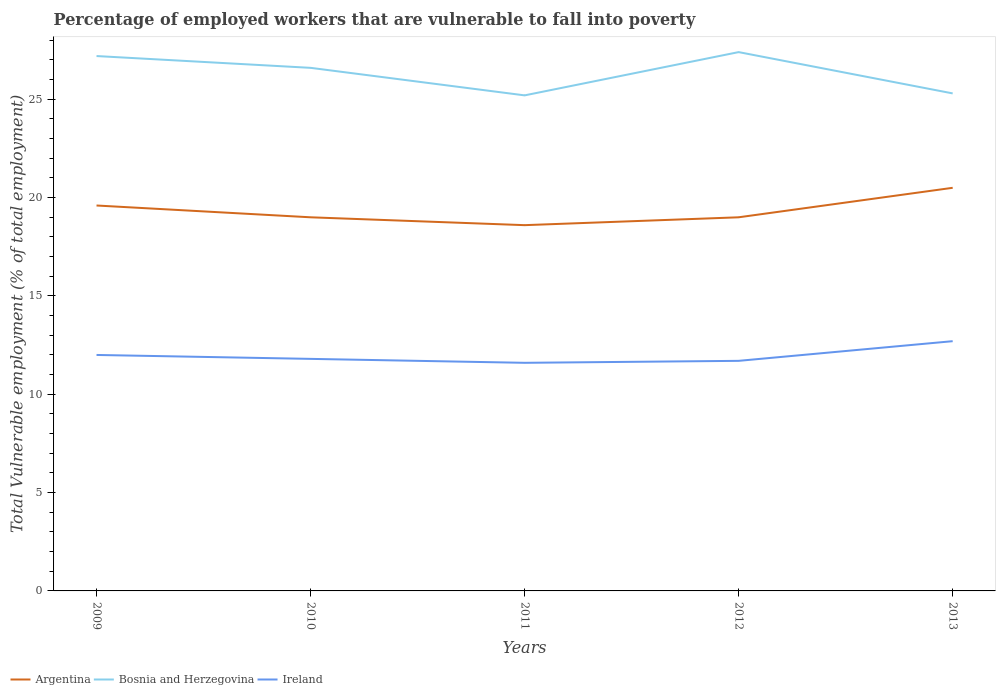How many different coloured lines are there?
Provide a short and direct response. 3. Across all years, what is the maximum percentage of employed workers who are vulnerable to fall into poverty in Ireland?
Offer a very short reply. 11.6. In which year was the percentage of employed workers who are vulnerable to fall into poverty in Ireland maximum?
Make the answer very short. 2011. What is the total percentage of employed workers who are vulnerable to fall into poverty in Argentina in the graph?
Offer a very short reply. 0.6. What is the difference between the highest and the second highest percentage of employed workers who are vulnerable to fall into poverty in Argentina?
Ensure brevity in your answer.  1.9. Is the percentage of employed workers who are vulnerable to fall into poverty in Argentina strictly greater than the percentage of employed workers who are vulnerable to fall into poverty in Bosnia and Herzegovina over the years?
Provide a short and direct response. Yes. How many lines are there?
Your response must be concise. 3. What is the difference between two consecutive major ticks on the Y-axis?
Offer a terse response. 5. Does the graph contain any zero values?
Keep it short and to the point. No. Does the graph contain grids?
Keep it short and to the point. No. Where does the legend appear in the graph?
Provide a short and direct response. Bottom left. How many legend labels are there?
Provide a succinct answer. 3. What is the title of the graph?
Your response must be concise. Percentage of employed workers that are vulnerable to fall into poverty. What is the label or title of the X-axis?
Ensure brevity in your answer.  Years. What is the label or title of the Y-axis?
Make the answer very short. Total Vulnerable employment (% of total employment). What is the Total Vulnerable employment (% of total employment) in Argentina in 2009?
Provide a succinct answer. 19.6. What is the Total Vulnerable employment (% of total employment) of Bosnia and Herzegovina in 2009?
Ensure brevity in your answer.  27.2. What is the Total Vulnerable employment (% of total employment) of Bosnia and Herzegovina in 2010?
Your response must be concise. 26.6. What is the Total Vulnerable employment (% of total employment) in Ireland in 2010?
Offer a very short reply. 11.8. What is the Total Vulnerable employment (% of total employment) in Argentina in 2011?
Offer a very short reply. 18.6. What is the Total Vulnerable employment (% of total employment) of Bosnia and Herzegovina in 2011?
Ensure brevity in your answer.  25.2. What is the Total Vulnerable employment (% of total employment) of Ireland in 2011?
Make the answer very short. 11.6. What is the Total Vulnerable employment (% of total employment) of Bosnia and Herzegovina in 2012?
Provide a succinct answer. 27.4. What is the Total Vulnerable employment (% of total employment) in Ireland in 2012?
Your answer should be compact. 11.7. What is the Total Vulnerable employment (% of total employment) in Argentina in 2013?
Provide a short and direct response. 20.5. What is the Total Vulnerable employment (% of total employment) of Bosnia and Herzegovina in 2013?
Your response must be concise. 25.3. What is the Total Vulnerable employment (% of total employment) in Ireland in 2013?
Your answer should be very brief. 12.7. Across all years, what is the maximum Total Vulnerable employment (% of total employment) of Argentina?
Your response must be concise. 20.5. Across all years, what is the maximum Total Vulnerable employment (% of total employment) of Bosnia and Herzegovina?
Keep it short and to the point. 27.4. Across all years, what is the maximum Total Vulnerable employment (% of total employment) of Ireland?
Offer a very short reply. 12.7. Across all years, what is the minimum Total Vulnerable employment (% of total employment) of Argentina?
Keep it short and to the point. 18.6. Across all years, what is the minimum Total Vulnerable employment (% of total employment) of Bosnia and Herzegovina?
Ensure brevity in your answer.  25.2. Across all years, what is the minimum Total Vulnerable employment (% of total employment) of Ireland?
Provide a short and direct response. 11.6. What is the total Total Vulnerable employment (% of total employment) in Argentina in the graph?
Make the answer very short. 96.7. What is the total Total Vulnerable employment (% of total employment) in Bosnia and Herzegovina in the graph?
Your answer should be very brief. 131.7. What is the total Total Vulnerable employment (% of total employment) of Ireland in the graph?
Give a very brief answer. 59.8. What is the difference between the Total Vulnerable employment (% of total employment) in Argentina in 2009 and that in 2010?
Offer a terse response. 0.6. What is the difference between the Total Vulnerable employment (% of total employment) of Argentina in 2009 and that in 2012?
Your answer should be compact. 0.6. What is the difference between the Total Vulnerable employment (% of total employment) of Ireland in 2009 and that in 2012?
Give a very brief answer. 0.3. What is the difference between the Total Vulnerable employment (% of total employment) in Ireland in 2009 and that in 2013?
Give a very brief answer. -0.7. What is the difference between the Total Vulnerable employment (% of total employment) of Ireland in 2010 and that in 2011?
Your answer should be compact. 0.2. What is the difference between the Total Vulnerable employment (% of total employment) of Ireland in 2010 and that in 2012?
Give a very brief answer. 0.1. What is the difference between the Total Vulnerable employment (% of total employment) in Argentina in 2010 and that in 2013?
Provide a short and direct response. -1.5. What is the difference between the Total Vulnerable employment (% of total employment) of Bosnia and Herzegovina in 2011 and that in 2012?
Make the answer very short. -2.2. What is the difference between the Total Vulnerable employment (% of total employment) of Argentina in 2011 and that in 2013?
Your answer should be very brief. -1.9. What is the difference between the Total Vulnerable employment (% of total employment) of Bosnia and Herzegovina in 2011 and that in 2013?
Offer a terse response. -0.1. What is the difference between the Total Vulnerable employment (% of total employment) in Argentina in 2012 and that in 2013?
Provide a succinct answer. -1.5. What is the difference between the Total Vulnerable employment (% of total employment) in Argentina in 2009 and the Total Vulnerable employment (% of total employment) in Bosnia and Herzegovina in 2010?
Offer a very short reply. -7. What is the difference between the Total Vulnerable employment (% of total employment) in Bosnia and Herzegovina in 2009 and the Total Vulnerable employment (% of total employment) in Ireland in 2010?
Your response must be concise. 15.4. What is the difference between the Total Vulnerable employment (% of total employment) in Argentina in 2009 and the Total Vulnerable employment (% of total employment) in Ireland in 2011?
Provide a short and direct response. 8. What is the difference between the Total Vulnerable employment (% of total employment) of Bosnia and Herzegovina in 2009 and the Total Vulnerable employment (% of total employment) of Ireland in 2011?
Your answer should be very brief. 15.6. What is the difference between the Total Vulnerable employment (% of total employment) of Argentina in 2009 and the Total Vulnerable employment (% of total employment) of Bosnia and Herzegovina in 2012?
Offer a very short reply. -7.8. What is the difference between the Total Vulnerable employment (% of total employment) in Argentina in 2009 and the Total Vulnerable employment (% of total employment) in Ireland in 2012?
Keep it short and to the point. 7.9. What is the difference between the Total Vulnerable employment (% of total employment) in Bosnia and Herzegovina in 2009 and the Total Vulnerable employment (% of total employment) in Ireland in 2012?
Make the answer very short. 15.5. What is the difference between the Total Vulnerable employment (% of total employment) of Argentina in 2009 and the Total Vulnerable employment (% of total employment) of Bosnia and Herzegovina in 2013?
Keep it short and to the point. -5.7. What is the difference between the Total Vulnerable employment (% of total employment) in Bosnia and Herzegovina in 2009 and the Total Vulnerable employment (% of total employment) in Ireland in 2013?
Ensure brevity in your answer.  14.5. What is the difference between the Total Vulnerable employment (% of total employment) in Argentina in 2010 and the Total Vulnerable employment (% of total employment) in Ireland in 2011?
Offer a terse response. 7.4. What is the difference between the Total Vulnerable employment (% of total employment) of Bosnia and Herzegovina in 2010 and the Total Vulnerable employment (% of total employment) of Ireland in 2011?
Provide a short and direct response. 15. What is the difference between the Total Vulnerable employment (% of total employment) in Bosnia and Herzegovina in 2010 and the Total Vulnerable employment (% of total employment) in Ireland in 2013?
Your response must be concise. 13.9. What is the difference between the Total Vulnerable employment (% of total employment) in Argentina in 2011 and the Total Vulnerable employment (% of total employment) in Ireland in 2013?
Give a very brief answer. 5.9. What is the difference between the Total Vulnerable employment (% of total employment) in Bosnia and Herzegovina in 2011 and the Total Vulnerable employment (% of total employment) in Ireland in 2013?
Your answer should be compact. 12.5. What is the difference between the Total Vulnerable employment (% of total employment) of Argentina in 2012 and the Total Vulnerable employment (% of total employment) of Bosnia and Herzegovina in 2013?
Your answer should be compact. -6.3. What is the difference between the Total Vulnerable employment (% of total employment) of Bosnia and Herzegovina in 2012 and the Total Vulnerable employment (% of total employment) of Ireland in 2013?
Provide a succinct answer. 14.7. What is the average Total Vulnerable employment (% of total employment) in Argentina per year?
Your response must be concise. 19.34. What is the average Total Vulnerable employment (% of total employment) in Bosnia and Herzegovina per year?
Your response must be concise. 26.34. What is the average Total Vulnerable employment (% of total employment) in Ireland per year?
Offer a terse response. 11.96. In the year 2009, what is the difference between the Total Vulnerable employment (% of total employment) of Argentina and Total Vulnerable employment (% of total employment) of Bosnia and Herzegovina?
Your response must be concise. -7.6. In the year 2010, what is the difference between the Total Vulnerable employment (% of total employment) of Argentina and Total Vulnerable employment (% of total employment) of Bosnia and Herzegovina?
Offer a terse response. -7.6. In the year 2010, what is the difference between the Total Vulnerable employment (% of total employment) of Argentina and Total Vulnerable employment (% of total employment) of Ireland?
Ensure brevity in your answer.  7.2. In the year 2011, what is the difference between the Total Vulnerable employment (% of total employment) in Bosnia and Herzegovina and Total Vulnerable employment (% of total employment) in Ireland?
Provide a short and direct response. 13.6. What is the ratio of the Total Vulnerable employment (% of total employment) in Argentina in 2009 to that in 2010?
Your response must be concise. 1.03. What is the ratio of the Total Vulnerable employment (% of total employment) in Bosnia and Herzegovina in 2009 to that in 2010?
Offer a very short reply. 1.02. What is the ratio of the Total Vulnerable employment (% of total employment) in Ireland in 2009 to that in 2010?
Ensure brevity in your answer.  1.02. What is the ratio of the Total Vulnerable employment (% of total employment) of Argentina in 2009 to that in 2011?
Provide a short and direct response. 1.05. What is the ratio of the Total Vulnerable employment (% of total employment) of Bosnia and Herzegovina in 2009 to that in 2011?
Provide a short and direct response. 1.08. What is the ratio of the Total Vulnerable employment (% of total employment) in Ireland in 2009 to that in 2011?
Provide a succinct answer. 1.03. What is the ratio of the Total Vulnerable employment (% of total employment) in Argentina in 2009 to that in 2012?
Offer a terse response. 1.03. What is the ratio of the Total Vulnerable employment (% of total employment) of Bosnia and Herzegovina in 2009 to that in 2012?
Provide a short and direct response. 0.99. What is the ratio of the Total Vulnerable employment (% of total employment) of Ireland in 2009 to that in 2012?
Your answer should be compact. 1.03. What is the ratio of the Total Vulnerable employment (% of total employment) of Argentina in 2009 to that in 2013?
Your response must be concise. 0.96. What is the ratio of the Total Vulnerable employment (% of total employment) in Bosnia and Herzegovina in 2009 to that in 2013?
Offer a terse response. 1.08. What is the ratio of the Total Vulnerable employment (% of total employment) in Ireland in 2009 to that in 2013?
Provide a succinct answer. 0.94. What is the ratio of the Total Vulnerable employment (% of total employment) of Argentina in 2010 to that in 2011?
Give a very brief answer. 1.02. What is the ratio of the Total Vulnerable employment (% of total employment) in Bosnia and Herzegovina in 2010 to that in 2011?
Your answer should be compact. 1.06. What is the ratio of the Total Vulnerable employment (% of total employment) in Ireland in 2010 to that in 2011?
Provide a succinct answer. 1.02. What is the ratio of the Total Vulnerable employment (% of total employment) of Argentina in 2010 to that in 2012?
Ensure brevity in your answer.  1. What is the ratio of the Total Vulnerable employment (% of total employment) in Bosnia and Herzegovina in 2010 to that in 2012?
Keep it short and to the point. 0.97. What is the ratio of the Total Vulnerable employment (% of total employment) in Ireland in 2010 to that in 2012?
Ensure brevity in your answer.  1.01. What is the ratio of the Total Vulnerable employment (% of total employment) of Argentina in 2010 to that in 2013?
Offer a very short reply. 0.93. What is the ratio of the Total Vulnerable employment (% of total employment) in Bosnia and Herzegovina in 2010 to that in 2013?
Give a very brief answer. 1.05. What is the ratio of the Total Vulnerable employment (% of total employment) in Ireland in 2010 to that in 2013?
Provide a short and direct response. 0.93. What is the ratio of the Total Vulnerable employment (% of total employment) of Argentina in 2011 to that in 2012?
Your answer should be compact. 0.98. What is the ratio of the Total Vulnerable employment (% of total employment) of Bosnia and Herzegovina in 2011 to that in 2012?
Your answer should be compact. 0.92. What is the ratio of the Total Vulnerable employment (% of total employment) of Argentina in 2011 to that in 2013?
Offer a terse response. 0.91. What is the ratio of the Total Vulnerable employment (% of total employment) of Bosnia and Herzegovina in 2011 to that in 2013?
Keep it short and to the point. 1. What is the ratio of the Total Vulnerable employment (% of total employment) in Ireland in 2011 to that in 2013?
Offer a terse response. 0.91. What is the ratio of the Total Vulnerable employment (% of total employment) of Argentina in 2012 to that in 2013?
Your answer should be compact. 0.93. What is the ratio of the Total Vulnerable employment (% of total employment) in Bosnia and Herzegovina in 2012 to that in 2013?
Offer a very short reply. 1.08. What is the ratio of the Total Vulnerable employment (% of total employment) of Ireland in 2012 to that in 2013?
Keep it short and to the point. 0.92. What is the difference between the highest and the lowest Total Vulnerable employment (% of total employment) of Argentina?
Ensure brevity in your answer.  1.9. What is the difference between the highest and the lowest Total Vulnerable employment (% of total employment) in Ireland?
Make the answer very short. 1.1. 